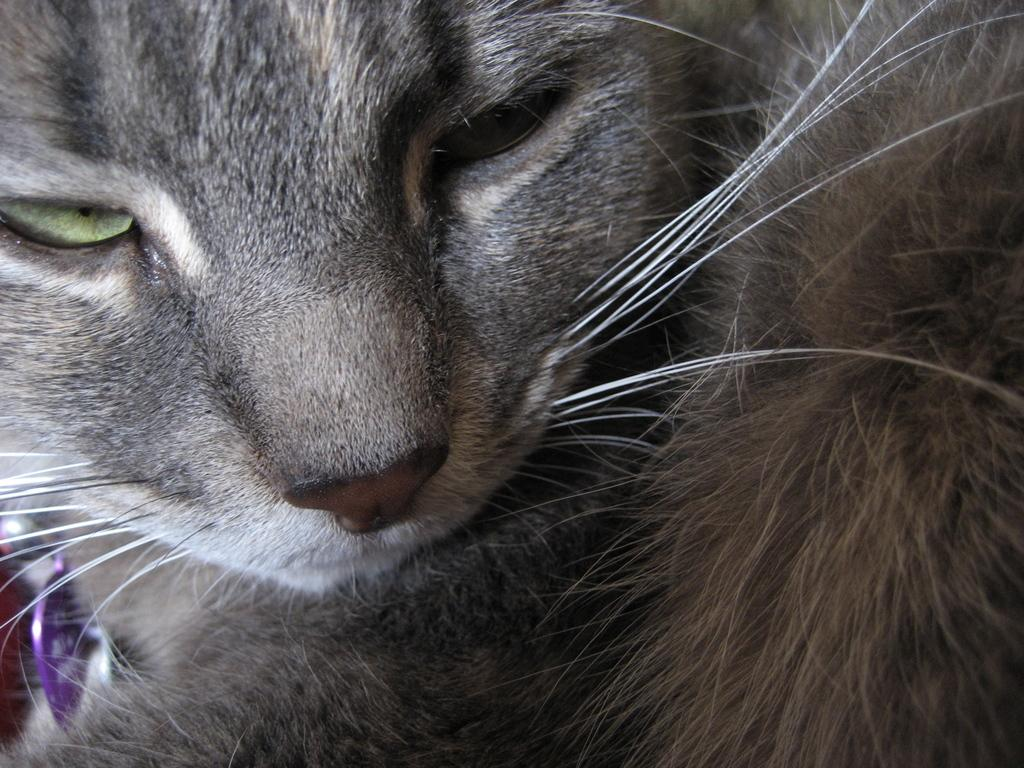What type of animal is in the image? There is a cat in the image. What color is the cat? The cat is grey in color. What type of haircut does the cat have in the image? There is no mention of a haircut for the cat in the image, as cats do not typically have haircuts. 